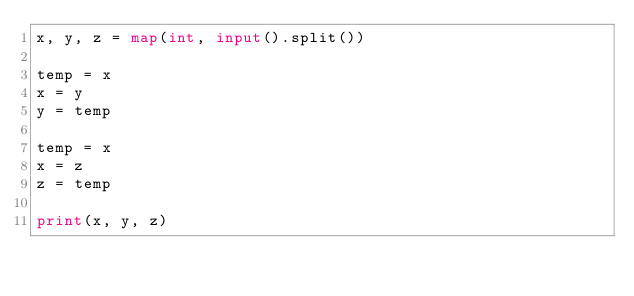<code> <loc_0><loc_0><loc_500><loc_500><_Python_>x, y, z = map(int, input().split())

temp = x
x = y
y = temp

temp = x
x = z
z = temp

print(x, y, z)</code> 